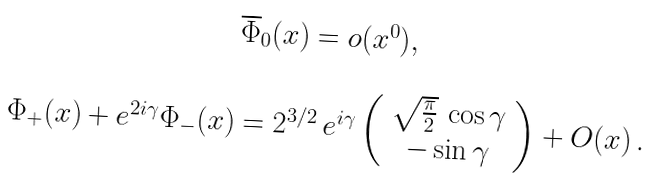<formula> <loc_0><loc_0><loc_500><loc_500>\begin{array} { c } \overline { \Phi } _ { 0 } ( x ) = o ( x ^ { 0 } ) , \\ \\ \Phi _ { + } ( x ) + e ^ { 2 i \gamma } \Phi _ { - } ( x ) = 2 ^ { 3 / 2 } \, e ^ { i \gamma } \left ( \begin{array} { c } \sqrt { \frac { \pi } { 2 } } \, \cos \gamma \\ - \sin \gamma \end{array} \right ) + O ( x ) \, . \end{array}</formula> 